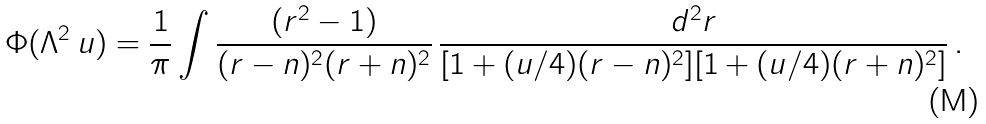Convert formula to latex. <formula><loc_0><loc_0><loc_500><loc_500>\Phi ( \Lambda ^ { 2 } \, u ) = { \frac { 1 } { \pi } } \int { \frac { ( { r } ^ { 2 } - 1 ) } { ( { r } - { n } ) ^ { 2 } ( { r } + { n } ) ^ { 2 } } } \, { \frac { d ^ { 2 } r } { [ 1 + ( u / 4 ) ( { r } - { n } ) ^ { 2 } ] [ 1 + ( u / 4 ) ( { r } + { n } ) ^ { 2 } ] } } \, .</formula> 